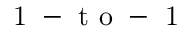Convert formula to latex. <formula><loc_0><loc_0><loc_500><loc_500>{ 1 - t o - 1 }</formula> 